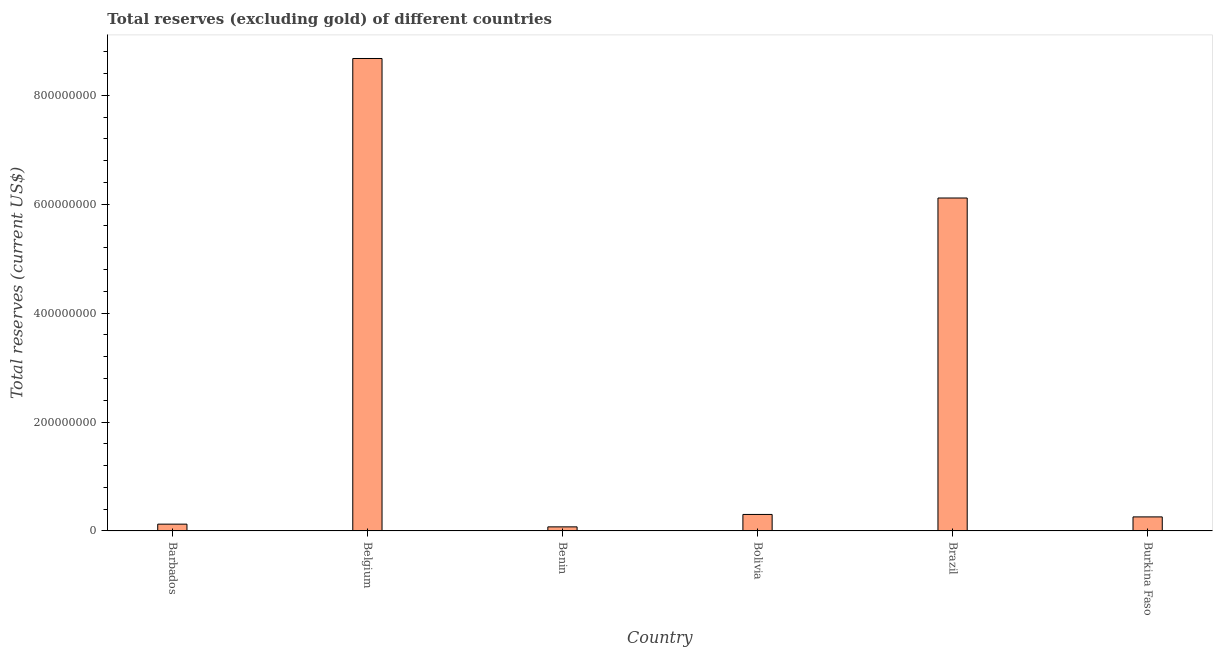Does the graph contain any zero values?
Ensure brevity in your answer.  No. What is the title of the graph?
Provide a short and direct response. Total reserves (excluding gold) of different countries. What is the label or title of the X-axis?
Offer a terse response. Country. What is the label or title of the Y-axis?
Your answer should be very brief. Total reserves (current US$). What is the total reserves (excluding gold) in Barbados?
Your response must be concise. 1.25e+07. Across all countries, what is the maximum total reserves (excluding gold)?
Provide a succinct answer. 8.67e+08. Across all countries, what is the minimum total reserves (excluding gold)?
Provide a short and direct response. 7.47e+06. In which country was the total reserves (excluding gold) minimum?
Provide a succinct answer. Benin. What is the sum of the total reserves (excluding gold)?
Your answer should be compact. 1.55e+09. What is the difference between the total reserves (excluding gold) in Belgium and Bolivia?
Provide a short and direct response. 8.37e+08. What is the average total reserves (excluding gold) per country?
Your answer should be compact. 2.59e+08. What is the median total reserves (excluding gold)?
Offer a terse response. 2.80e+07. In how many countries, is the total reserves (excluding gold) greater than 600000000 US$?
Your response must be concise. 2. What is the ratio of the total reserves (excluding gold) in Belgium to that in Brazil?
Ensure brevity in your answer.  1.42. Is the total reserves (excluding gold) in Barbados less than that in Belgium?
Keep it short and to the point. Yes. Is the difference between the total reserves (excluding gold) in Bolivia and Brazil greater than the difference between any two countries?
Offer a terse response. No. What is the difference between the highest and the second highest total reserves (excluding gold)?
Provide a succinct answer. 2.56e+08. Is the sum of the total reserves (excluding gold) in Belgium and Burkina Faso greater than the maximum total reserves (excluding gold) across all countries?
Offer a very short reply. Yes. What is the difference between the highest and the lowest total reserves (excluding gold)?
Keep it short and to the point. 8.60e+08. In how many countries, is the total reserves (excluding gold) greater than the average total reserves (excluding gold) taken over all countries?
Your answer should be very brief. 2. Are all the bars in the graph horizontal?
Your response must be concise. No. How many countries are there in the graph?
Provide a short and direct response. 6. What is the difference between two consecutive major ticks on the Y-axis?
Provide a succinct answer. 2.00e+08. Are the values on the major ticks of Y-axis written in scientific E-notation?
Ensure brevity in your answer.  No. What is the Total reserves (current US$) in Barbados?
Ensure brevity in your answer.  1.25e+07. What is the Total reserves (current US$) in Belgium?
Make the answer very short. 8.67e+08. What is the Total reserves (current US$) of Benin?
Your answer should be compact. 7.47e+06. What is the Total reserves (current US$) of Bolivia?
Provide a short and direct response. 3.03e+07. What is the Total reserves (current US$) of Brazil?
Provide a succinct answer. 6.11e+08. What is the Total reserves (current US$) of Burkina Faso?
Make the answer very short. 2.58e+07. What is the difference between the Total reserves (current US$) in Barbados and Belgium?
Your answer should be compact. -8.55e+08. What is the difference between the Total reserves (current US$) in Barbados and Benin?
Provide a short and direct response. 5.00e+06. What is the difference between the Total reserves (current US$) in Barbados and Bolivia?
Offer a very short reply. -1.78e+07. What is the difference between the Total reserves (current US$) in Barbados and Brazil?
Offer a very short reply. -5.99e+08. What is the difference between the Total reserves (current US$) in Barbados and Burkina Faso?
Keep it short and to the point. -1.33e+07. What is the difference between the Total reserves (current US$) in Belgium and Benin?
Keep it short and to the point. 8.60e+08. What is the difference between the Total reserves (current US$) in Belgium and Bolivia?
Your response must be concise. 8.37e+08. What is the difference between the Total reserves (current US$) in Belgium and Brazil?
Your answer should be compact. 2.56e+08. What is the difference between the Total reserves (current US$) in Belgium and Burkina Faso?
Your answer should be compact. 8.42e+08. What is the difference between the Total reserves (current US$) in Benin and Bolivia?
Your response must be concise. -2.28e+07. What is the difference between the Total reserves (current US$) in Benin and Brazil?
Keep it short and to the point. -6.04e+08. What is the difference between the Total reserves (current US$) in Benin and Burkina Faso?
Your answer should be very brief. -1.83e+07. What is the difference between the Total reserves (current US$) in Bolivia and Brazil?
Make the answer very short. -5.81e+08. What is the difference between the Total reserves (current US$) in Bolivia and Burkina Faso?
Provide a succinct answer. 4.52e+06. What is the difference between the Total reserves (current US$) in Brazil and Burkina Faso?
Provide a short and direct response. 5.86e+08. What is the ratio of the Total reserves (current US$) in Barbados to that in Belgium?
Offer a very short reply. 0.01. What is the ratio of the Total reserves (current US$) in Barbados to that in Benin?
Offer a very short reply. 1.67. What is the ratio of the Total reserves (current US$) in Barbados to that in Bolivia?
Offer a very short reply. 0.41. What is the ratio of the Total reserves (current US$) in Barbados to that in Burkina Faso?
Provide a short and direct response. 0.48. What is the ratio of the Total reserves (current US$) in Belgium to that in Benin?
Give a very brief answer. 116.13. What is the ratio of the Total reserves (current US$) in Belgium to that in Bolivia?
Provide a succinct answer. 28.63. What is the ratio of the Total reserves (current US$) in Belgium to that in Brazil?
Provide a short and direct response. 1.42. What is the ratio of the Total reserves (current US$) in Belgium to that in Burkina Faso?
Make the answer very short. 33.65. What is the ratio of the Total reserves (current US$) in Benin to that in Bolivia?
Your answer should be compact. 0.25. What is the ratio of the Total reserves (current US$) in Benin to that in Brazil?
Offer a terse response. 0.01. What is the ratio of the Total reserves (current US$) in Benin to that in Burkina Faso?
Make the answer very short. 0.29. What is the ratio of the Total reserves (current US$) in Bolivia to that in Burkina Faso?
Keep it short and to the point. 1.18. What is the ratio of the Total reserves (current US$) in Brazil to that in Burkina Faso?
Offer a terse response. 23.71. 